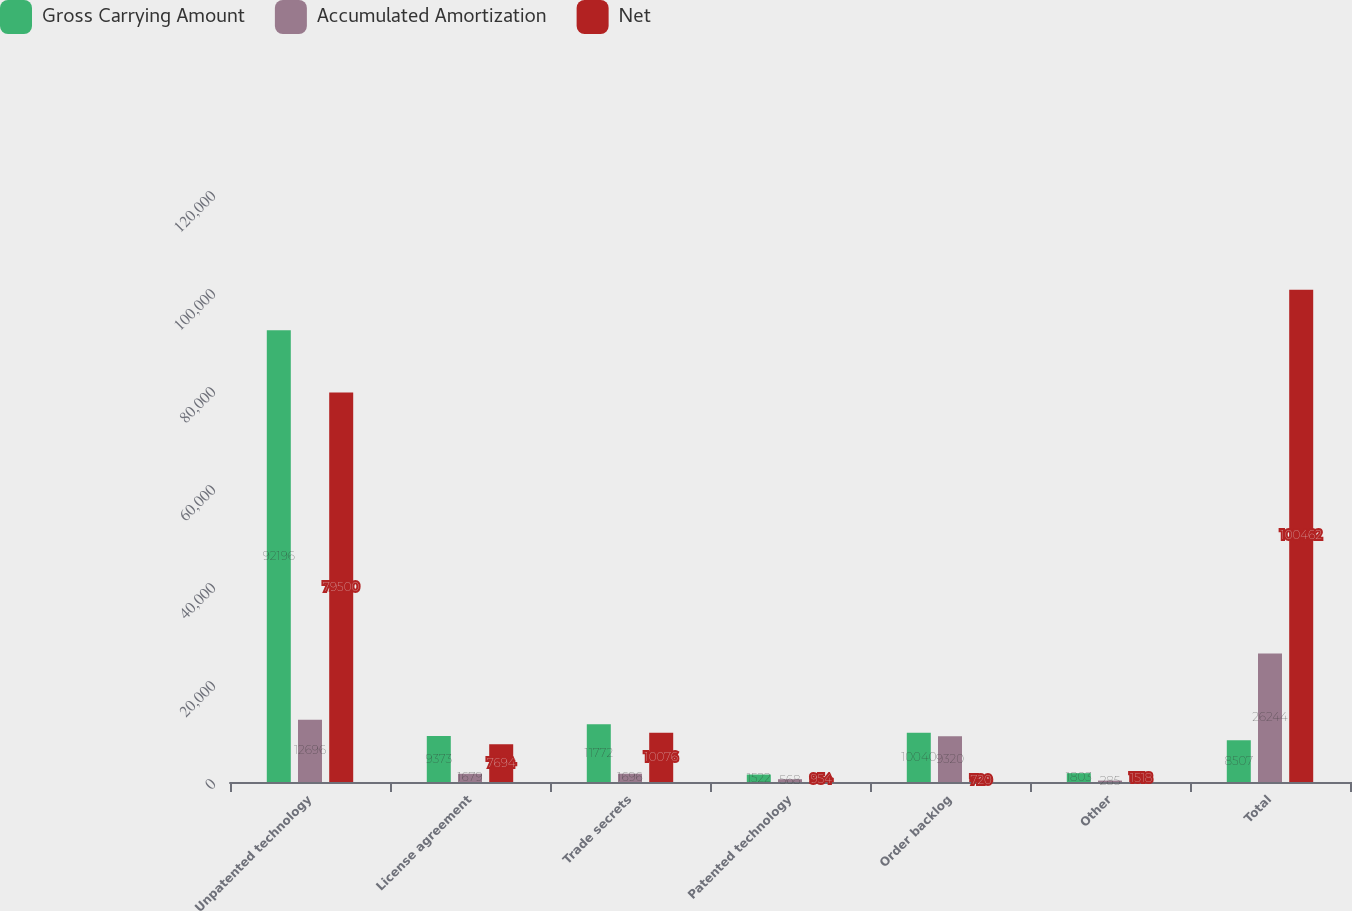Convert chart to OTSL. <chart><loc_0><loc_0><loc_500><loc_500><stacked_bar_chart><ecel><fcel>Unpatented technology<fcel>License agreement<fcel>Trade secrets<fcel>Patented technology<fcel>Order backlog<fcel>Other<fcel>Total<nl><fcel>Gross Carrying Amount<fcel>92196<fcel>9373<fcel>11772<fcel>1522<fcel>10040<fcel>1803<fcel>8507<nl><fcel>Accumulated Amortization<fcel>12696<fcel>1679<fcel>1696<fcel>568<fcel>9320<fcel>285<fcel>26244<nl><fcel>Net<fcel>79500<fcel>7694<fcel>10076<fcel>954<fcel>720<fcel>1518<fcel>100462<nl></chart> 